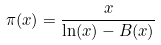<formula> <loc_0><loc_0><loc_500><loc_500>\pi ( x ) = { \frac { x } { \ln ( x ) - B ( x ) } }</formula> 